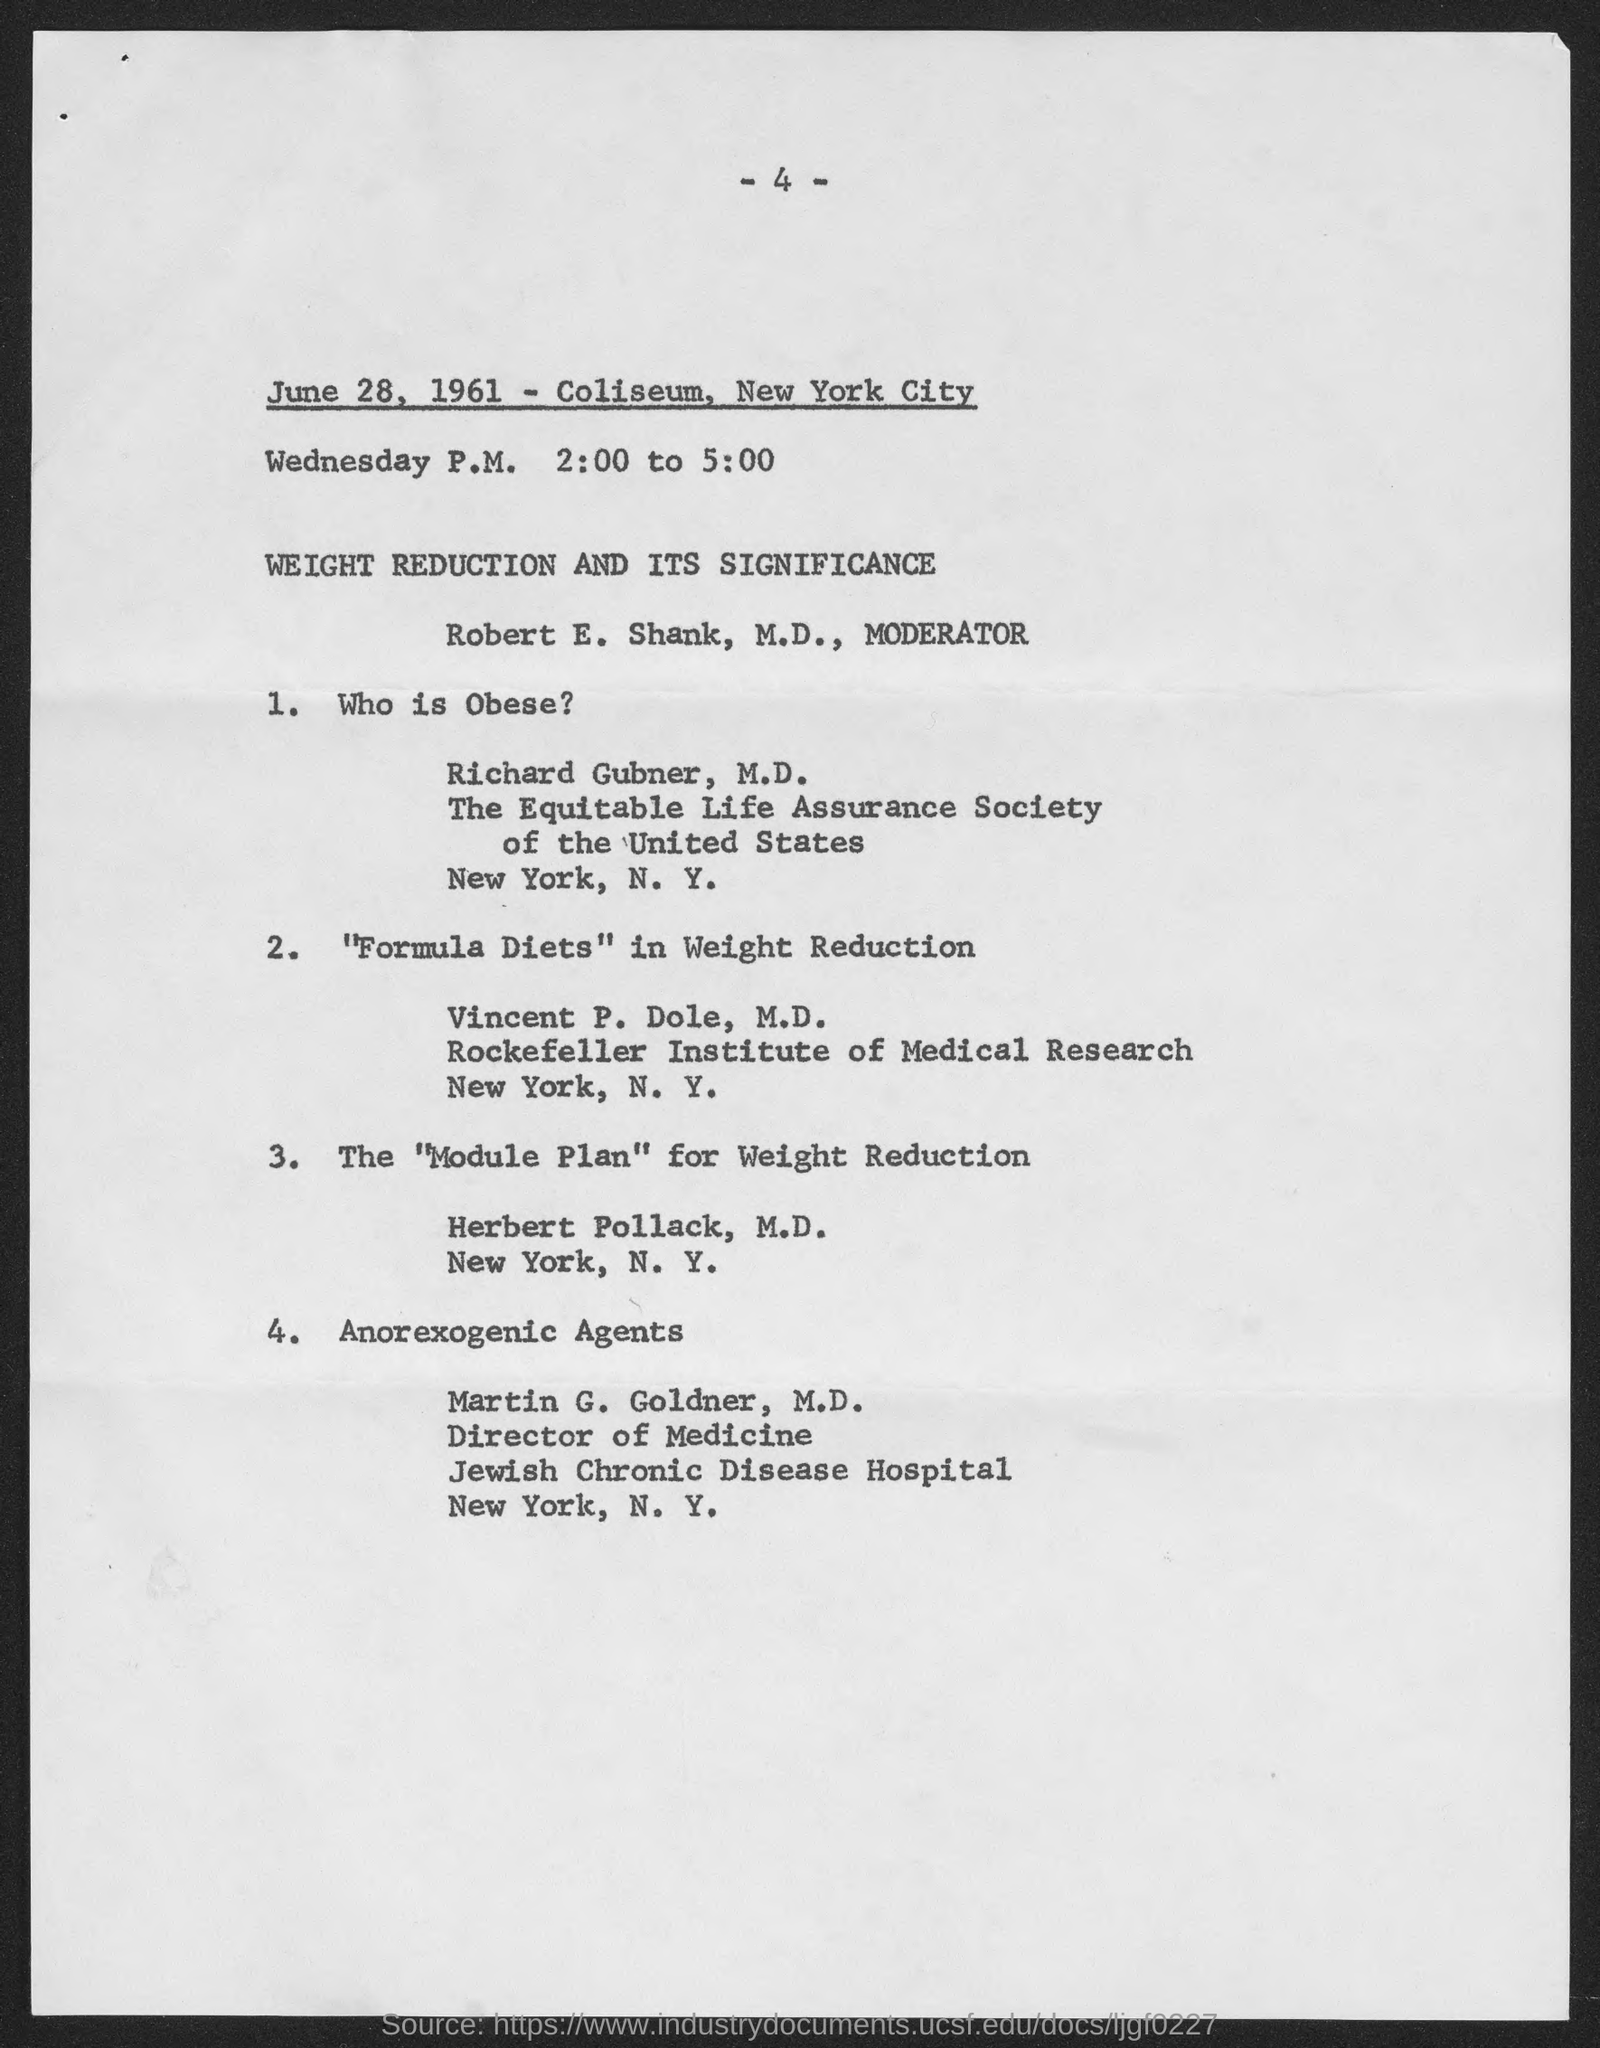Highlight a few significant elements in this photo. The "Anorexogenic Agents" are used at the Jewish Chronic Disease Hospital. Richard Gubner is obese. Formula diets are created for the purpose of weight reduction. The Director of Medicine is Martin G. Goldner, M.D. The individual named Robert E. Shank is the moderator. 